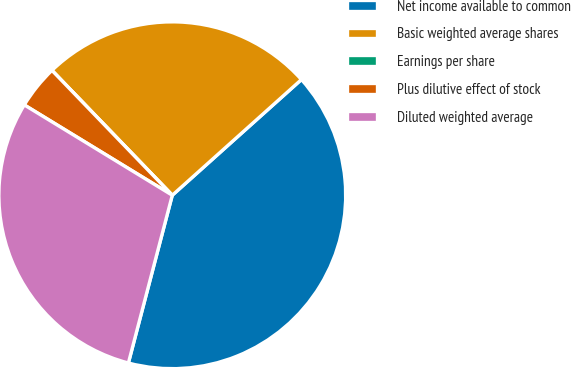Convert chart to OTSL. <chart><loc_0><loc_0><loc_500><loc_500><pie_chart><fcel>Net income available to common<fcel>Basic weighted average shares<fcel>Earnings per share<fcel>Plus dilutive effect of stock<fcel>Diluted weighted average<nl><fcel>40.7%<fcel>25.58%<fcel>0.0%<fcel>4.07%<fcel>29.65%<nl></chart> 